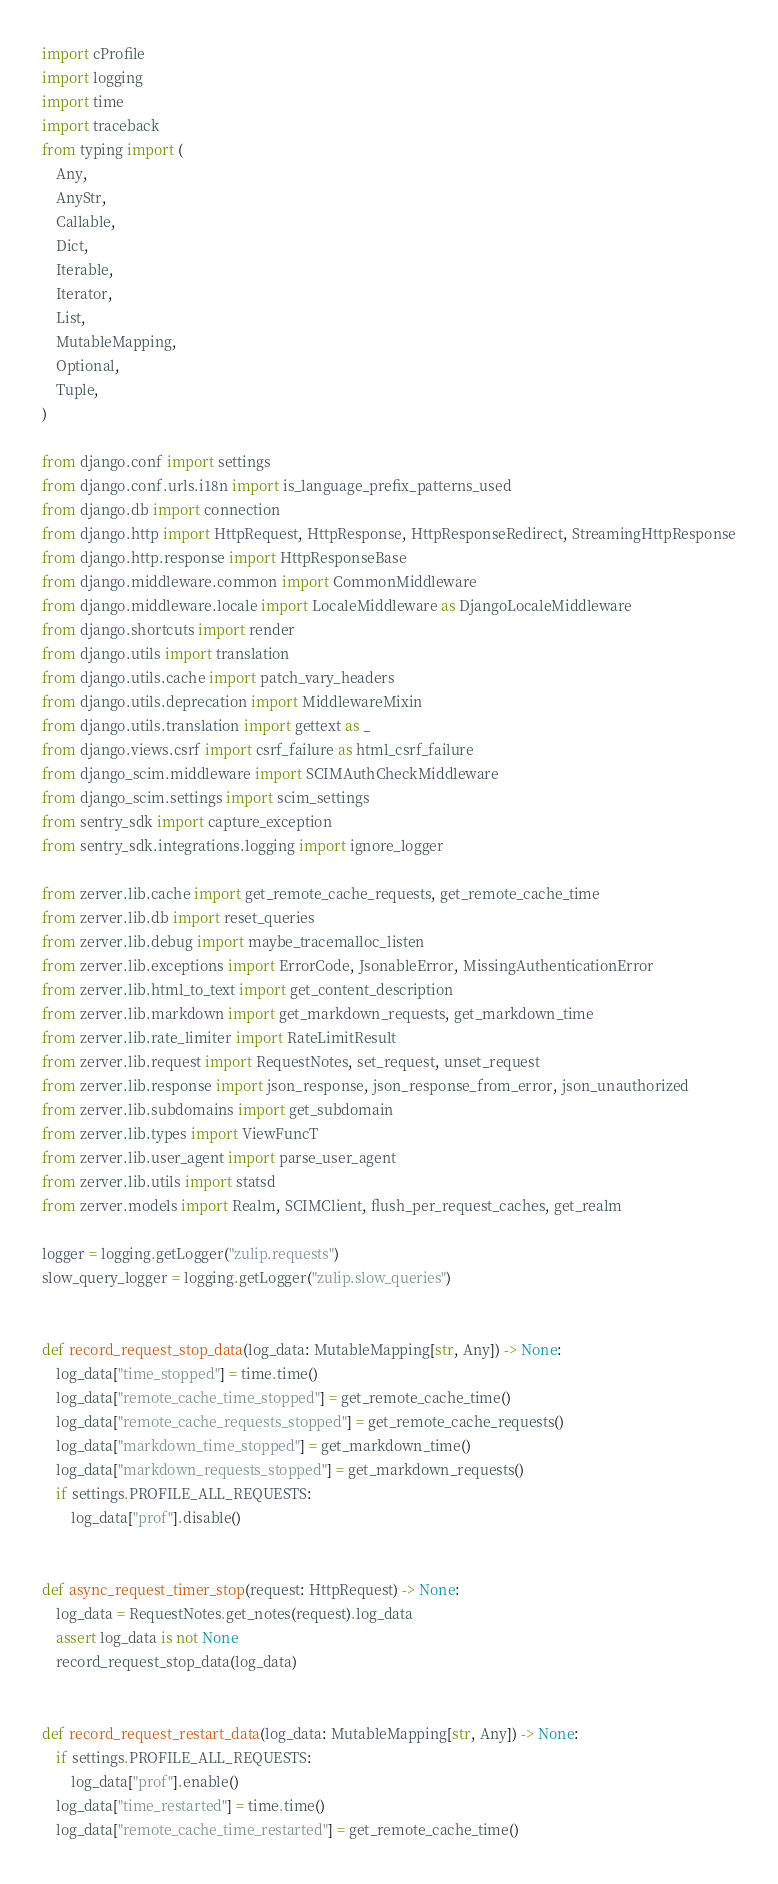<code> <loc_0><loc_0><loc_500><loc_500><_Python_>import cProfile
import logging
import time
import traceback
from typing import (
    Any,
    AnyStr,
    Callable,
    Dict,
    Iterable,
    Iterator,
    List,
    MutableMapping,
    Optional,
    Tuple,
)

from django.conf import settings
from django.conf.urls.i18n import is_language_prefix_patterns_used
from django.db import connection
from django.http import HttpRequest, HttpResponse, HttpResponseRedirect, StreamingHttpResponse
from django.http.response import HttpResponseBase
from django.middleware.common import CommonMiddleware
from django.middleware.locale import LocaleMiddleware as DjangoLocaleMiddleware
from django.shortcuts import render
from django.utils import translation
from django.utils.cache import patch_vary_headers
from django.utils.deprecation import MiddlewareMixin
from django.utils.translation import gettext as _
from django.views.csrf import csrf_failure as html_csrf_failure
from django_scim.middleware import SCIMAuthCheckMiddleware
from django_scim.settings import scim_settings
from sentry_sdk import capture_exception
from sentry_sdk.integrations.logging import ignore_logger

from zerver.lib.cache import get_remote_cache_requests, get_remote_cache_time
from zerver.lib.db import reset_queries
from zerver.lib.debug import maybe_tracemalloc_listen
from zerver.lib.exceptions import ErrorCode, JsonableError, MissingAuthenticationError
from zerver.lib.html_to_text import get_content_description
from zerver.lib.markdown import get_markdown_requests, get_markdown_time
from zerver.lib.rate_limiter import RateLimitResult
from zerver.lib.request import RequestNotes, set_request, unset_request
from zerver.lib.response import json_response, json_response_from_error, json_unauthorized
from zerver.lib.subdomains import get_subdomain
from zerver.lib.types import ViewFuncT
from zerver.lib.user_agent import parse_user_agent
from zerver.lib.utils import statsd
from zerver.models import Realm, SCIMClient, flush_per_request_caches, get_realm

logger = logging.getLogger("zulip.requests")
slow_query_logger = logging.getLogger("zulip.slow_queries")


def record_request_stop_data(log_data: MutableMapping[str, Any]) -> None:
    log_data["time_stopped"] = time.time()
    log_data["remote_cache_time_stopped"] = get_remote_cache_time()
    log_data["remote_cache_requests_stopped"] = get_remote_cache_requests()
    log_data["markdown_time_stopped"] = get_markdown_time()
    log_data["markdown_requests_stopped"] = get_markdown_requests()
    if settings.PROFILE_ALL_REQUESTS:
        log_data["prof"].disable()


def async_request_timer_stop(request: HttpRequest) -> None:
    log_data = RequestNotes.get_notes(request).log_data
    assert log_data is not None
    record_request_stop_data(log_data)


def record_request_restart_data(log_data: MutableMapping[str, Any]) -> None:
    if settings.PROFILE_ALL_REQUESTS:
        log_data["prof"].enable()
    log_data["time_restarted"] = time.time()
    log_data["remote_cache_time_restarted"] = get_remote_cache_time()</code> 